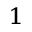Convert formula to latex. <formula><loc_0><loc_0><loc_500><loc_500>^ { 1 }</formula> 